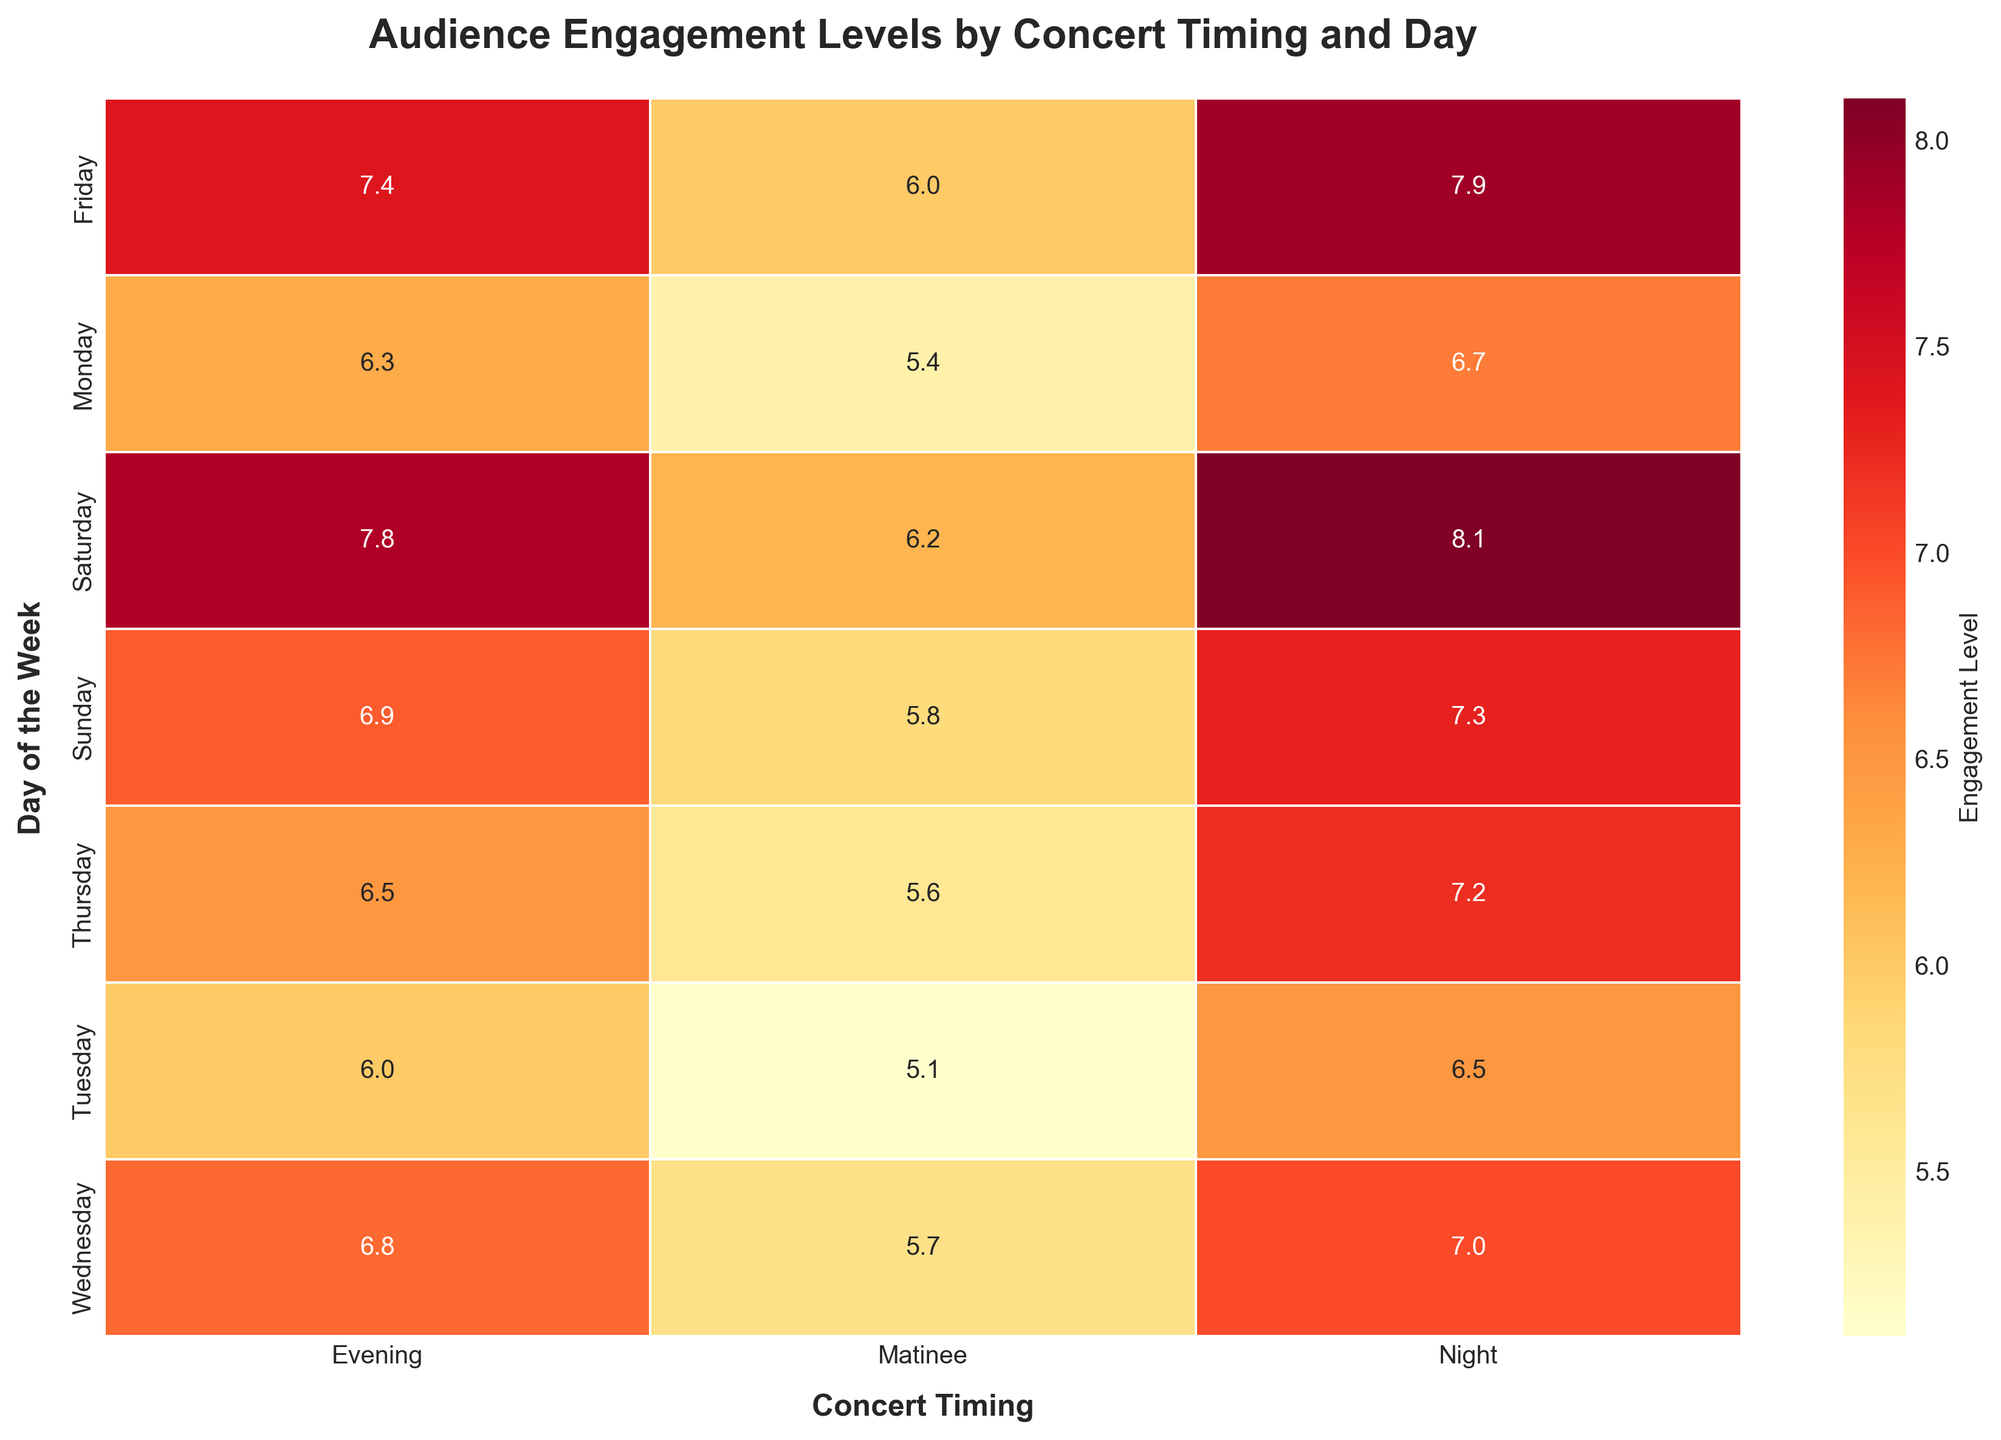What is the title of the heatmap? The title of the heatmap is located at the top and provides an overview of what the figure represents. "Audience Engagement Levels by Concert Timing and Day" is clearly written as the title.
Answer: Audience Engagement Levels by Concert Timing and Day On which day and concert timing is the highest engagement level observed? To find the highest engagement level, we look for the highest number in the heatmap. The value 8.1 is observed on Saturday during the Night timing.
Answer: Saturday Night What is the engagement level for a matinee concert on Wednesday? We locate Wednesday on the y-axis and then find the corresponding value under the Matinee column. The intersection shows the value 5.7.
Answer: 5.7 Which concert timing generally has the highest engagement levels across all days? By comparing all engagement levels horizontally across the columns (Matinee, Evening, and Night), we observe that the Night column consistently has the highest values compared to the others.
Answer: Night How does the engagement level on Sunday Evening compare to Saturday Evening? To compare the engagement levels, we look at the values for Sunday Evening and Saturday Evening. The engagement level on Sunday Evening is 6.9, while on Saturday Evening it is 7.8. Thus, Saturday Evening has higher engagement.
Answer: Saturday Evening is higher What is the average engagement level for concerts on Tuesday? We find the values for Tuesday (5.1 Matinee, 6.0 Evening, 6.5 Night) and calculate their average: (5.1 + 6.0 + 6.5) / 3 = 5.87.
Answer: 5.87 Which day has the lowest engagement level for Matinee concerts? We compare the engagement levels for Matinee concerts across all days and find that Tuesday has the lowest value, which is 5.1.
Answer: Tuesday Is there a noticeable trend in engagement levels from Monday to Sunday for Night concerts? To identify a trend, we examine the Night concert values from Monday to Sunday: 6.7, 6.5, 7.0, 7.2, 7.9, 8.1, 7.3. The engagement levels generally increase from Monday to Saturday and slightly decrease on Sunday.
Answer: Generally increasing What is the difference in engagement levels between Friday Matinee and Friday Night concerts? We look at the values for Friday Matinee (6.0) and Friday Night (7.9) and calculate the difference: 7.9 - 6.0 = 1.9.
Answer: 1.9 